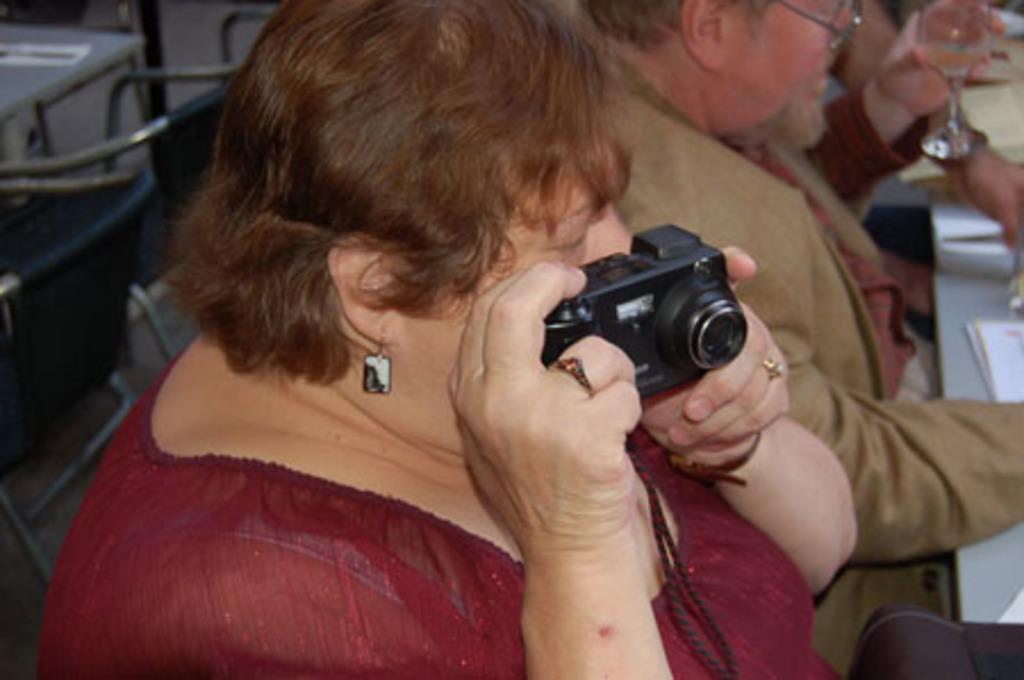Please provide a concise description of this image. This image is taken in indoors. In this image we can see two persons a man and a woman. In the left side of the image we can see an empty chairs and a table. In the right side of the image we can see a table which has books on it. In the middle of the image there is a woman holding a camera in hand. 